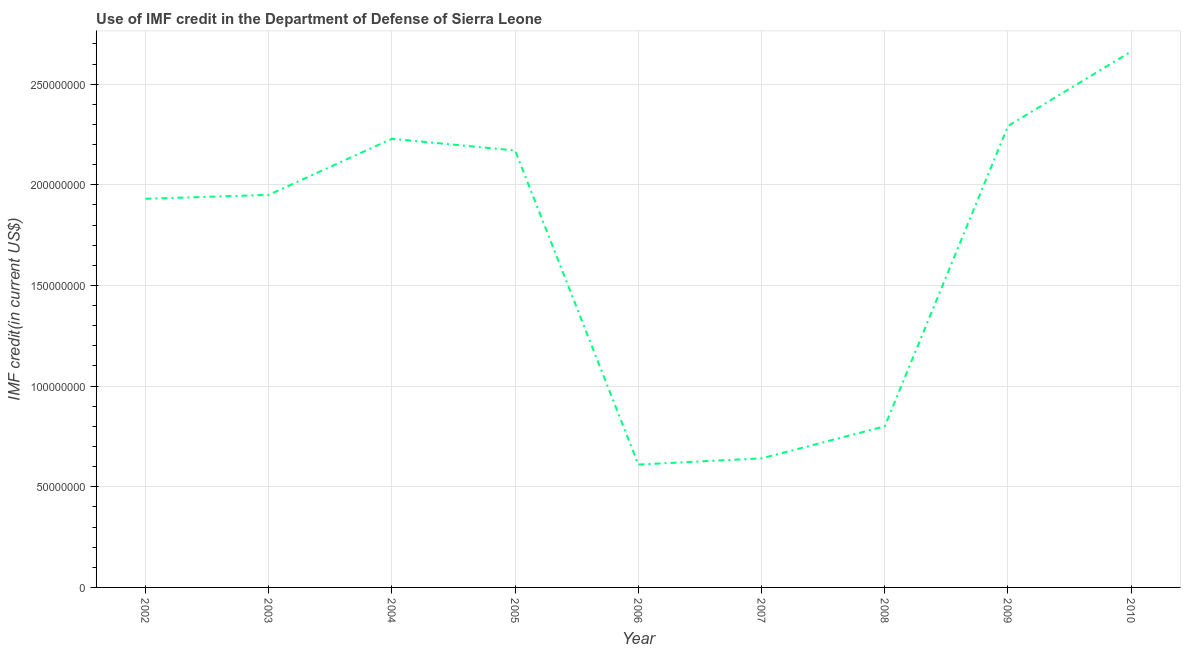What is the use of imf credit in dod in 2008?
Ensure brevity in your answer.  8.00e+07. Across all years, what is the maximum use of imf credit in dod?
Your response must be concise. 2.66e+08. Across all years, what is the minimum use of imf credit in dod?
Offer a terse response. 6.10e+07. In which year was the use of imf credit in dod minimum?
Provide a short and direct response. 2006. What is the sum of the use of imf credit in dod?
Your answer should be compact. 1.53e+09. What is the difference between the use of imf credit in dod in 2008 and 2009?
Ensure brevity in your answer.  -1.49e+08. What is the average use of imf credit in dod per year?
Your answer should be very brief. 1.70e+08. What is the median use of imf credit in dod?
Make the answer very short. 1.95e+08. What is the ratio of the use of imf credit in dod in 2004 to that in 2008?
Offer a very short reply. 2.78. Is the difference between the use of imf credit in dod in 2002 and 2009 greater than the difference between any two years?
Your answer should be very brief. No. What is the difference between the highest and the second highest use of imf credit in dod?
Your response must be concise. 3.70e+07. Is the sum of the use of imf credit in dod in 2006 and 2008 greater than the maximum use of imf credit in dod across all years?
Make the answer very short. No. What is the difference between the highest and the lowest use of imf credit in dod?
Keep it short and to the point. 2.05e+08. How many years are there in the graph?
Provide a succinct answer. 9. What is the difference between two consecutive major ticks on the Y-axis?
Offer a terse response. 5.00e+07. Are the values on the major ticks of Y-axis written in scientific E-notation?
Provide a short and direct response. No. Does the graph contain any zero values?
Your response must be concise. No. Does the graph contain grids?
Your response must be concise. Yes. What is the title of the graph?
Your answer should be very brief. Use of IMF credit in the Department of Defense of Sierra Leone. What is the label or title of the Y-axis?
Offer a terse response. IMF credit(in current US$). What is the IMF credit(in current US$) of 2002?
Your response must be concise. 1.93e+08. What is the IMF credit(in current US$) in 2003?
Your answer should be compact. 1.95e+08. What is the IMF credit(in current US$) of 2004?
Offer a very short reply. 2.23e+08. What is the IMF credit(in current US$) of 2005?
Offer a terse response. 2.17e+08. What is the IMF credit(in current US$) of 2006?
Provide a short and direct response. 6.10e+07. What is the IMF credit(in current US$) of 2007?
Offer a very short reply. 6.41e+07. What is the IMF credit(in current US$) of 2008?
Ensure brevity in your answer.  8.00e+07. What is the IMF credit(in current US$) in 2009?
Your answer should be compact. 2.29e+08. What is the IMF credit(in current US$) of 2010?
Provide a succinct answer. 2.66e+08. What is the difference between the IMF credit(in current US$) in 2002 and 2003?
Your answer should be compact. -1.95e+06. What is the difference between the IMF credit(in current US$) in 2002 and 2004?
Provide a short and direct response. -2.98e+07. What is the difference between the IMF credit(in current US$) in 2002 and 2005?
Make the answer very short. -2.40e+07. What is the difference between the IMF credit(in current US$) in 2002 and 2006?
Offer a terse response. 1.32e+08. What is the difference between the IMF credit(in current US$) in 2002 and 2007?
Ensure brevity in your answer.  1.29e+08. What is the difference between the IMF credit(in current US$) in 2002 and 2008?
Ensure brevity in your answer.  1.13e+08. What is the difference between the IMF credit(in current US$) in 2002 and 2009?
Your response must be concise. -3.62e+07. What is the difference between the IMF credit(in current US$) in 2002 and 2010?
Your answer should be very brief. -7.32e+07. What is the difference between the IMF credit(in current US$) in 2003 and 2004?
Your answer should be compact. -2.79e+07. What is the difference between the IMF credit(in current US$) in 2003 and 2005?
Keep it short and to the point. -2.20e+07. What is the difference between the IMF credit(in current US$) in 2003 and 2006?
Your answer should be very brief. 1.34e+08. What is the difference between the IMF credit(in current US$) in 2003 and 2007?
Provide a short and direct response. 1.31e+08. What is the difference between the IMF credit(in current US$) in 2003 and 2008?
Your answer should be very brief. 1.15e+08. What is the difference between the IMF credit(in current US$) in 2003 and 2009?
Keep it short and to the point. -3.42e+07. What is the difference between the IMF credit(in current US$) in 2003 and 2010?
Your answer should be very brief. -7.12e+07. What is the difference between the IMF credit(in current US$) in 2004 and 2005?
Keep it short and to the point. 5.83e+06. What is the difference between the IMF credit(in current US$) in 2004 and 2006?
Provide a succinct answer. 1.62e+08. What is the difference between the IMF credit(in current US$) in 2004 and 2007?
Offer a terse response. 1.59e+08. What is the difference between the IMF credit(in current US$) in 2004 and 2008?
Your answer should be compact. 1.43e+08. What is the difference between the IMF credit(in current US$) in 2004 and 2009?
Your answer should be very brief. -6.34e+06. What is the difference between the IMF credit(in current US$) in 2004 and 2010?
Keep it short and to the point. -4.34e+07. What is the difference between the IMF credit(in current US$) in 2005 and 2006?
Your answer should be compact. 1.56e+08. What is the difference between the IMF credit(in current US$) in 2005 and 2007?
Give a very brief answer. 1.53e+08. What is the difference between the IMF credit(in current US$) in 2005 and 2008?
Offer a terse response. 1.37e+08. What is the difference between the IMF credit(in current US$) in 2005 and 2009?
Make the answer very short. -1.22e+07. What is the difference between the IMF credit(in current US$) in 2005 and 2010?
Your answer should be compact. -4.92e+07. What is the difference between the IMF credit(in current US$) in 2006 and 2007?
Keep it short and to the point. -3.08e+06. What is the difference between the IMF credit(in current US$) in 2006 and 2008?
Your answer should be compact. -1.90e+07. What is the difference between the IMF credit(in current US$) in 2006 and 2009?
Offer a very short reply. -1.68e+08. What is the difference between the IMF credit(in current US$) in 2006 and 2010?
Offer a terse response. -2.05e+08. What is the difference between the IMF credit(in current US$) in 2007 and 2008?
Your answer should be compact. -1.59e+07. What is the difference between the IMF credit(in current US$) in 2007 and 2009?
Offer a very short reply. -1.65e+08. What is the difference between the IMF credit(in current US$) in 2007 and 2010?
Provide a succinct answer. -2.02e+08. What is the difference between the IMF credit(in current US$) in 2008 and 2009?
Provide a short and direct response. -1.49e+08. What is the difference between the IMF credit(in current US$) in 2008 and 2010?
Your answer should be very brief. -1.86e+08. What is the difference between the IMF credit(in current US$) in 2009 and 2010?
Provide a succinct answer. -3.70e+07. What is the ratio of the IMF credit(in current US$) in 2002 to that in 2004?
Your answer should be very brief. 0.87. What is the ratio of the IMF credit(in current US$) in 2002 to that in 2005?
Ensure brevity in your answer.  0.89. What is the ratio of the IMF credit(in current US$) in 2002 to that in 2006?
Make the answer very short. 3.16. What is the ratio of the IMF credit(in current US$) in 2002 to that in 2007?
Your answer should be compact. 3.01. What is the ratio of the IMF credit(in current US$) in 2002 to that in 2008?
Give a very brief answer. 2.41. What is the ratio of the IMF credit(in current US$) in 2002 to that in 2009?
Provide a short and direct response. 0.84. What is the ratio of the IMF credit(in current US$) in 2002 to that in 2010?
Your response must be concise. 0.72. What is the ratio of the IMF credit(in current US$) in 2003 to that in 2004?
Your response must be concise. 0.88. What is the ratio of the IMF credit(in current US$) in 2003 to that in 2005?
Give a very brief answer. 0.9. What is the ratio of the IMF credit(in current US$) in 2003 to that in 2006?
Offer a terse response. 3.19. What is the ratio of the IMF credit(in current US$) in 2003 to that in 2007?
Your answer should be compact. 3.04. What is the ratio of the IMF credit(in current US$) in 2003 to that in 2008?
Provide a succinct answer. 2.44. What is the ratio of the IMF credit(in current US$) in 2003 to that in 2009?
Offer a terse response. 0.85. What is the ratio of the IMF credit(in current US$) in 2003 to that in 2010?
Offer a very short reply. 0.73. What is the ratio of the IMF credit(in current US$) in 2004 to that in 2006?
Offer a terse response. 3.65. What is the ratio of the IMF credit(in current US$) in 2004 to that in 2007?
Offer a very short reply. 3.48. What is the ratio of the IMF credit(in current US$) in 2004 to that in 2008?
Offer a very short reply. 2.78. What is the ratio of the IMF credit(in current US$) in 2004 to that in 2010?
Your response must be concise. 0.84. What is the ratio of the IMF credit(in current US$) in 2005 to that in 2006?
Give a very brief answer. 3.56. What is the ratio of the IMF credit(in current US$) in 2005 to that in 2007?
Provide a short and direct response. 3.38. What is the ratio of the IMF credit(in current US$) in 2005 to that in 2008?
Your answer should be compact. 2.71. What is the ratio of the IMF credit(in current US$) in 2005 to that in 2009?
Your response must be concise. 0.95. What is the ratio of the IMF credit(in current US$) in 2005 to that in 2010?
Your response must be concise. 0.81. What is the ratio of the IMF credit(in current US$) in 2006 to that in 2007?
Your answer should be compact. 0.95. What is the ratio of the IMF credit(in current US$) in 2006 to that in 2008?
Make the answer very short. 0.76. What is the ratio of the IMF credit(in current US$) in 2006 to that in 2009?
Provide a short and direct response. 0.27. What is the ratio of the IMF credit(in current US$) in 2006 to that in 2010?
Your response must be concise. 0.23. What is the ratio of the IMF credit(in current US$) in 2007 to that in 2008?
Provide a succinct answer. 0.8. What is the ratio of the IMF credit(in current US$) in 2007 to that in 2009?
Offer a very short reply. 0.28. What is the ratio of the IMF credit(in current US$) in 2007 to that in 2010?
Your answer should be very brief. 0.24. What is the ratio of the IMF credit(in current US$) in 2008 to that in 2009?
Your response must be concise. 0.35. What is the ratio of the IMF credit(in current US$) in 2008 to that in 2010?
Offer a very short reply. 0.3. What is the ratio of the IMF credit(in current US$) in 2009 to that in 2010?
Offer a very short reply. 0.86. 